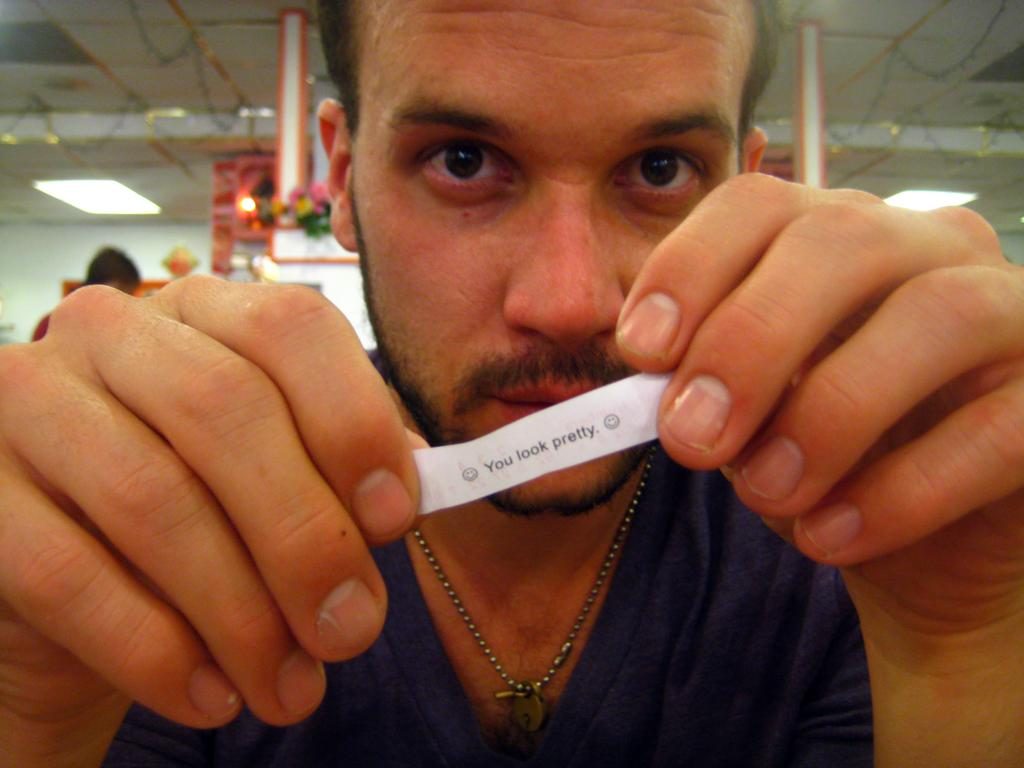Who is present in the image? There is a man in the image. What is the man holding in the image? The man is holding a piece of paper. What can be seen in the background of the image? There are lights and other objects visible in the background of the image. How many friends is the man flying with in the image? There is no plane or friends present in the image; it only features a man holding a piece of paper. What is the name of the man's son in the image? There is no mention of a son in the image; it only features a man holding a piece of paper. 